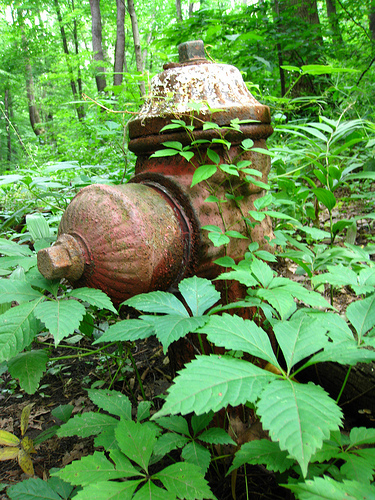Describe the condition and surroundings of the object in the image. The fire hydrant in the picture appears old and rusty, indicating lack of recent maintenance. It is surrounded by lush green vegetation, possibly located in a forest or overgrown area, giving it an almost forgotten look. What could have caused the fire hydrant to be in such a state? The fire hydrant may have been neglected for a long time, leading to rust and wear. Over time, the surrounding vegetation has grown extensively, contributing to its current overgrown and abandoned condition. This scenario could result from the area no longer being actively monitored or maintained. How does this image make you feel? This image evokes a sense of nostalgia and curiosity. The juxtaposition of man-made infrastructure with nature's reclaiming presence creates a compelling narrative of time, neglect, and the unstoppable force of nature. Imagine the life story of this fire hydrant. Tell a detailed creative story of its journey from installation to its current state. Once vibrant and freshly painted, the fire hydrant was installed many decades ago when this area was undergoing urban development. It served diligently, being a crucial part of the firefighting efforts of its time. Children played around it, and on more than one occasion, it was a hero, gushing water to extinguish flames and save homes. However, as the development plans changed and the area became less populated, the hydrant saw less use. As years rolled by, the community dwindled, and eventually, the area was abandoned. Nature began to reclaim the land. Vines and shrubs grew, slowly enveloping the once-active hydrant. Now, it stands as a relic of the past, silently witnessing the transformation of its surroundings from bustling suburbia to a tranquil, green haven. 